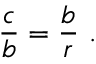Convert formula to latex. <formula><loc_0><loc_0><loc_500><loc_500>{ \frac { c } { b } } = { \frac { b } { r } } \ .</formula> 